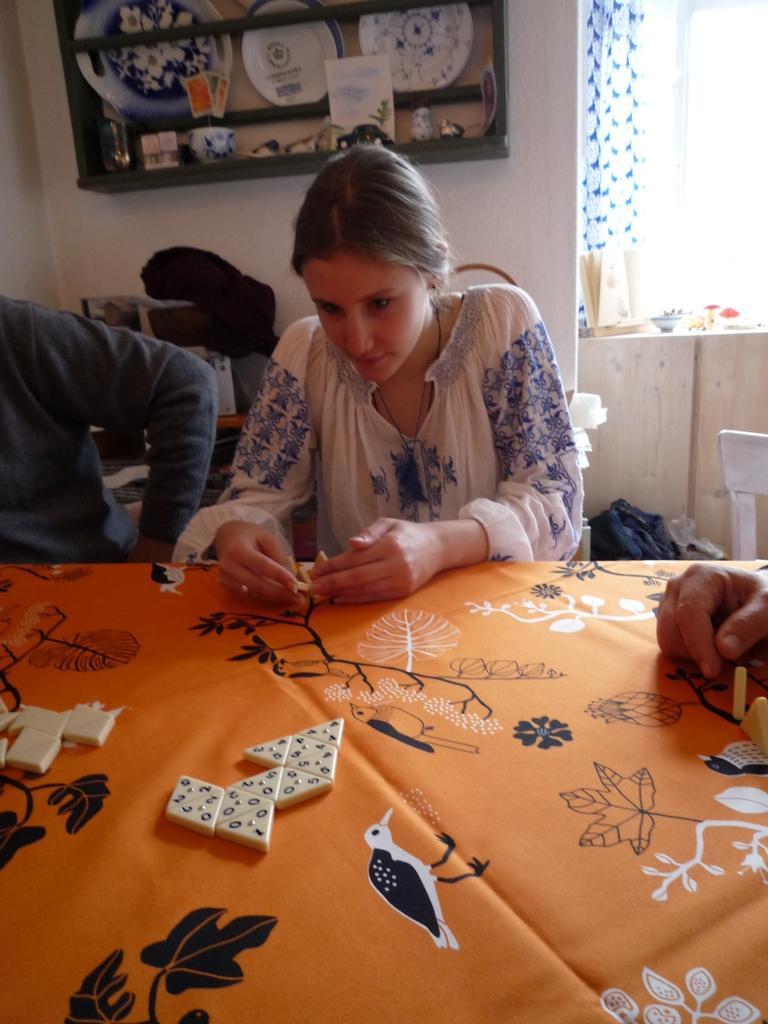In one or two sentences, can you explain what this image depicts? This picture shows two people seated on the chairs and we see a woman playing a game and we see a shelf on her back 